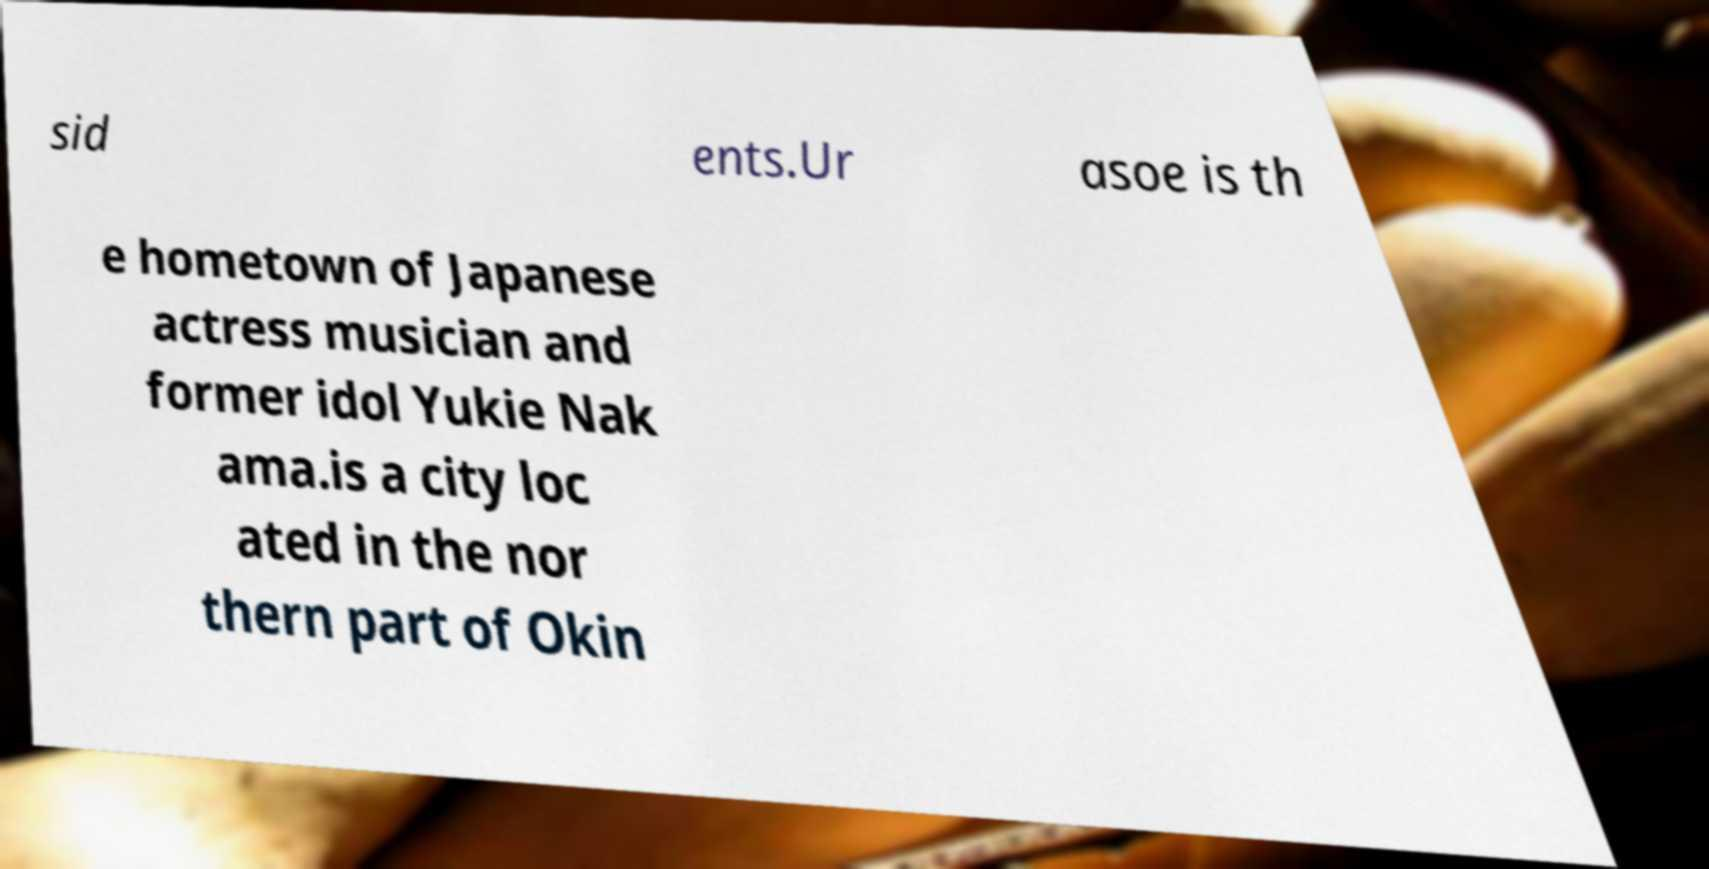Can you accurately transcribe the text from the provided image for me? sid ents.Ur asoe is th e hometown of Japanese actress musician and former idol Yukie Nak ama.is a city loc ated in the nor thern part of Okin 